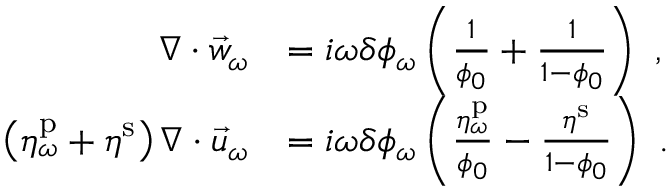Convert formula to latex. <formula><loc_0><loc_0><loc_500><loc_500>\begin{array} { r l } { \nabla \cdot \vec { w } _ { \omega } } & { = i \omega \delta \phi _ { \omega } \left ( \frac { 1 } { \phi _ { 0 } } + \frac { 1 } { 1 - \phi _ { 0 } } \right ) \ , } \\ { \left ( \eta _ { \omega } ^ { p } + \eta ^ { s } \right ) \nabla \cdot \vec { u } _ { \omega } } & { = i \omega \delta \phi _ { \omega } \left ( \frac { \eta _ { \omega } ^ { p } } { \phi _ { 0 } } - \frac { \eta ^ { s } } { 1 - \phi _ { 0 } } \right ) \ . } \end{array}</formula> 